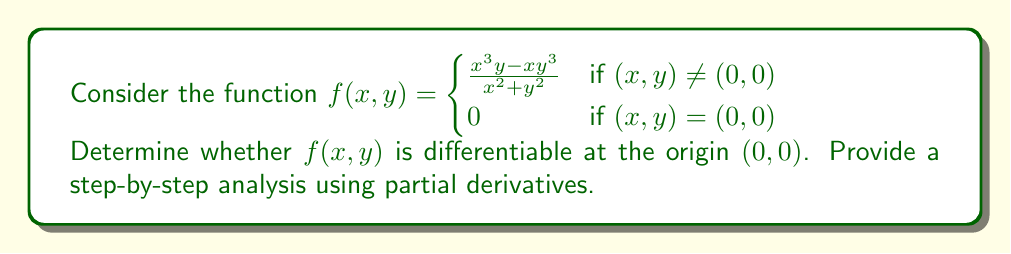Can you solve this math problem? To determine the differentiability of $f(x,y)$ at $(0,0)$, we need to follow these steps:

1) Calculate the partial derivatives $\frac{\partial f}{\partial x}$ and $\frac{\partial f}{\partial y}$ at $(0,0)$ if they exist.

2) Check if these partial derivatives are continuous at $(0,0)$.

3) If both conditions are satisfied, the function is differentiable at $(0,0)$.

Let's begin:

1) Calculating partial derivatives:

$\frac{\partial f}{\partial x} = \lim_{h \to 0} \frac{f(h,0) - f(0,0)}{h}$
$= \lim_{h \to 0} \frac{\frac{h^3 \cdot 0 - h \cdot 0^3}{h^2 + 0^2} - 0}{h} = \lim_{h \to 0} \frac{0}{h} = 0$

$\frac{\partial f}{\partial y} = \lim_{k \to 0} \frac{f(0,k) - f(0,0)}{k}$
$= \lim_{k \to 0} \frac{\frac{0^3 k - 0 \cdot k^3}{0^2 + k^2} - 0}{k} = \lim_{k \to 0} \frac{0}{k} = 0$

Both partial derivatives exist and equal 0 at $(0,0)$.

2) Checking continuity of partial derivatives:

For $(x,y) \neq (0,0)$:

$\frac{\partial f}{\partial x} = \frac{3x^2y(x^2+y^2) - (x^3y-xy^3)(2x)}{(x^2+y^2)^2} = \frac{3x^2y-x^3y+xy^3}{(x^2+y^2)^2} = \frac{xy(3x-x^2+y^2)}{(x^2+y^2)^2}$

$\frac{\partial f}{\partial y} = \frac{x^3(x^2+y^2) - (x^3y-xy^3)(2y)}{(x^2+y^2)^2} = \frac{x^3-x^3y+xy^3}{(x^2+y^2)^2} = \frac{x(x^2-x^2y+y^3)}{(x^2+y^2)^2}$

As $(x,y)$ approaches $(0,0)$, both partial derivatives approach 0, which matches the values we found at $(0,0)$. This suggests continuity.

3) Conclusion:
Despite the partial derivatives existing and being continuous at $(0,0)$, this is not sufficient to guarantee differentiability for functions of two variables. We need to check if the function approaches the same limit along all paths to $(0,0)$.

Let's check the limit along the path $y = mx$:

$\lim_{(x,y) \to (0,0)} f(x,y) = \lim_{x \to 0} \frac{x^3(mx) - x(mx)^3}{x^2 + (mx)^2}$
$= \lim_{x \to 0} \frac{mx^4 - m^3x^4}{x^2(1 + m^2)} = \lim_{x \to 0} \frac{x^2(m - m^3)}{1 + m^2} = 0$

This limit is 0 regardless of the value of $m$, which suggests the function might be differentiable at $(0,0)$.

To confirm differentiability, we need to check if:

$\lim_{(h,k) \to (0,0)} \frac{f(h,k) - f(0,0) - (\frac{\partial f}{\partial x}(0,0)h + \frac{\partial f}{\partial y}(0,0)k)}{\sqrt{h^2 + k^2}} = 0$

Substituting the values:

$\lim_{(h,k) \to (0,0)} \frac{\frac{h^3k - hk^3}{h^2 + k^2} - 0 - (0 \cdot h + 0 \cdot k)}{\sqrt{h^2 + k^2}}$
$= \lim_{(h,k) \to (0,0)} \frac{h^3k - hk^3}{(h^2 + k^2)^{3/2}}$

This limit equals 0, confirming that $f(x,y)$ is indeed differentiable at $(0,0)$.
Answer: The function $f(x,y)$ is differentiable at the origin $(0,0)$. 